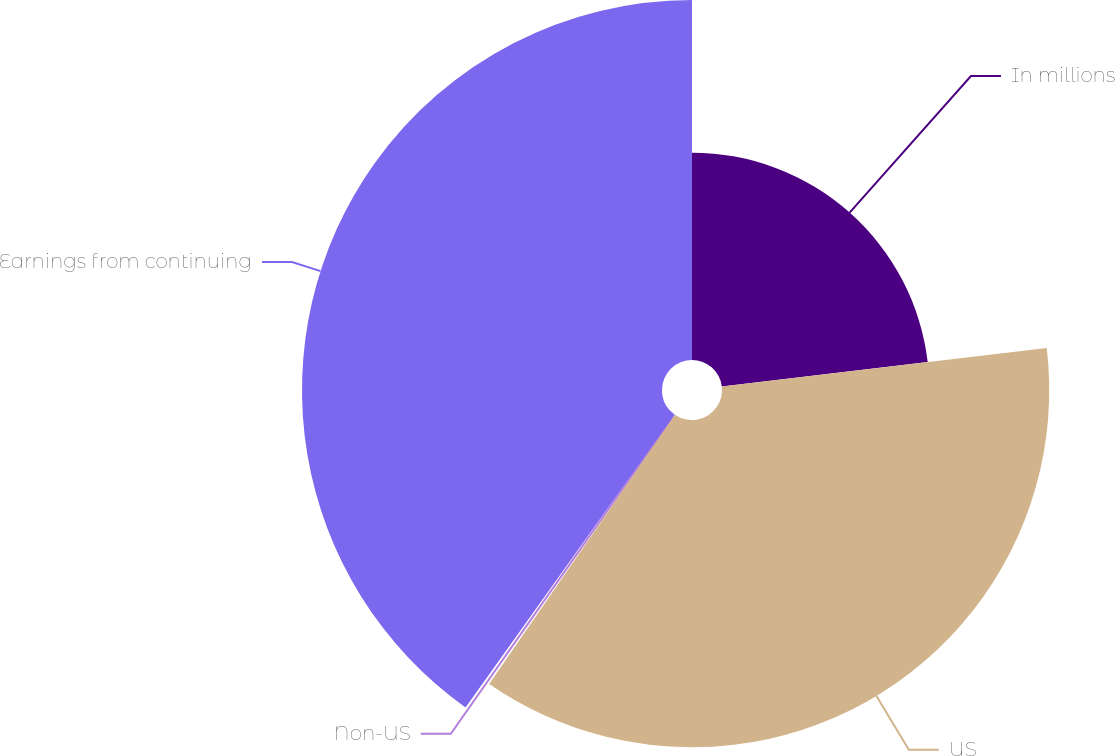Convert chart to OTSL. <chart><loc_0><loc_0><loc_500><loc_500><pie_chart><fcel>In millions<fcel>US<fcel>Non-US<fcel>Earnings from continuing<nl><fcel>23.12%<fcel>36.49%<fcel>0.25%<fcel>40.14%<nl></chart> 